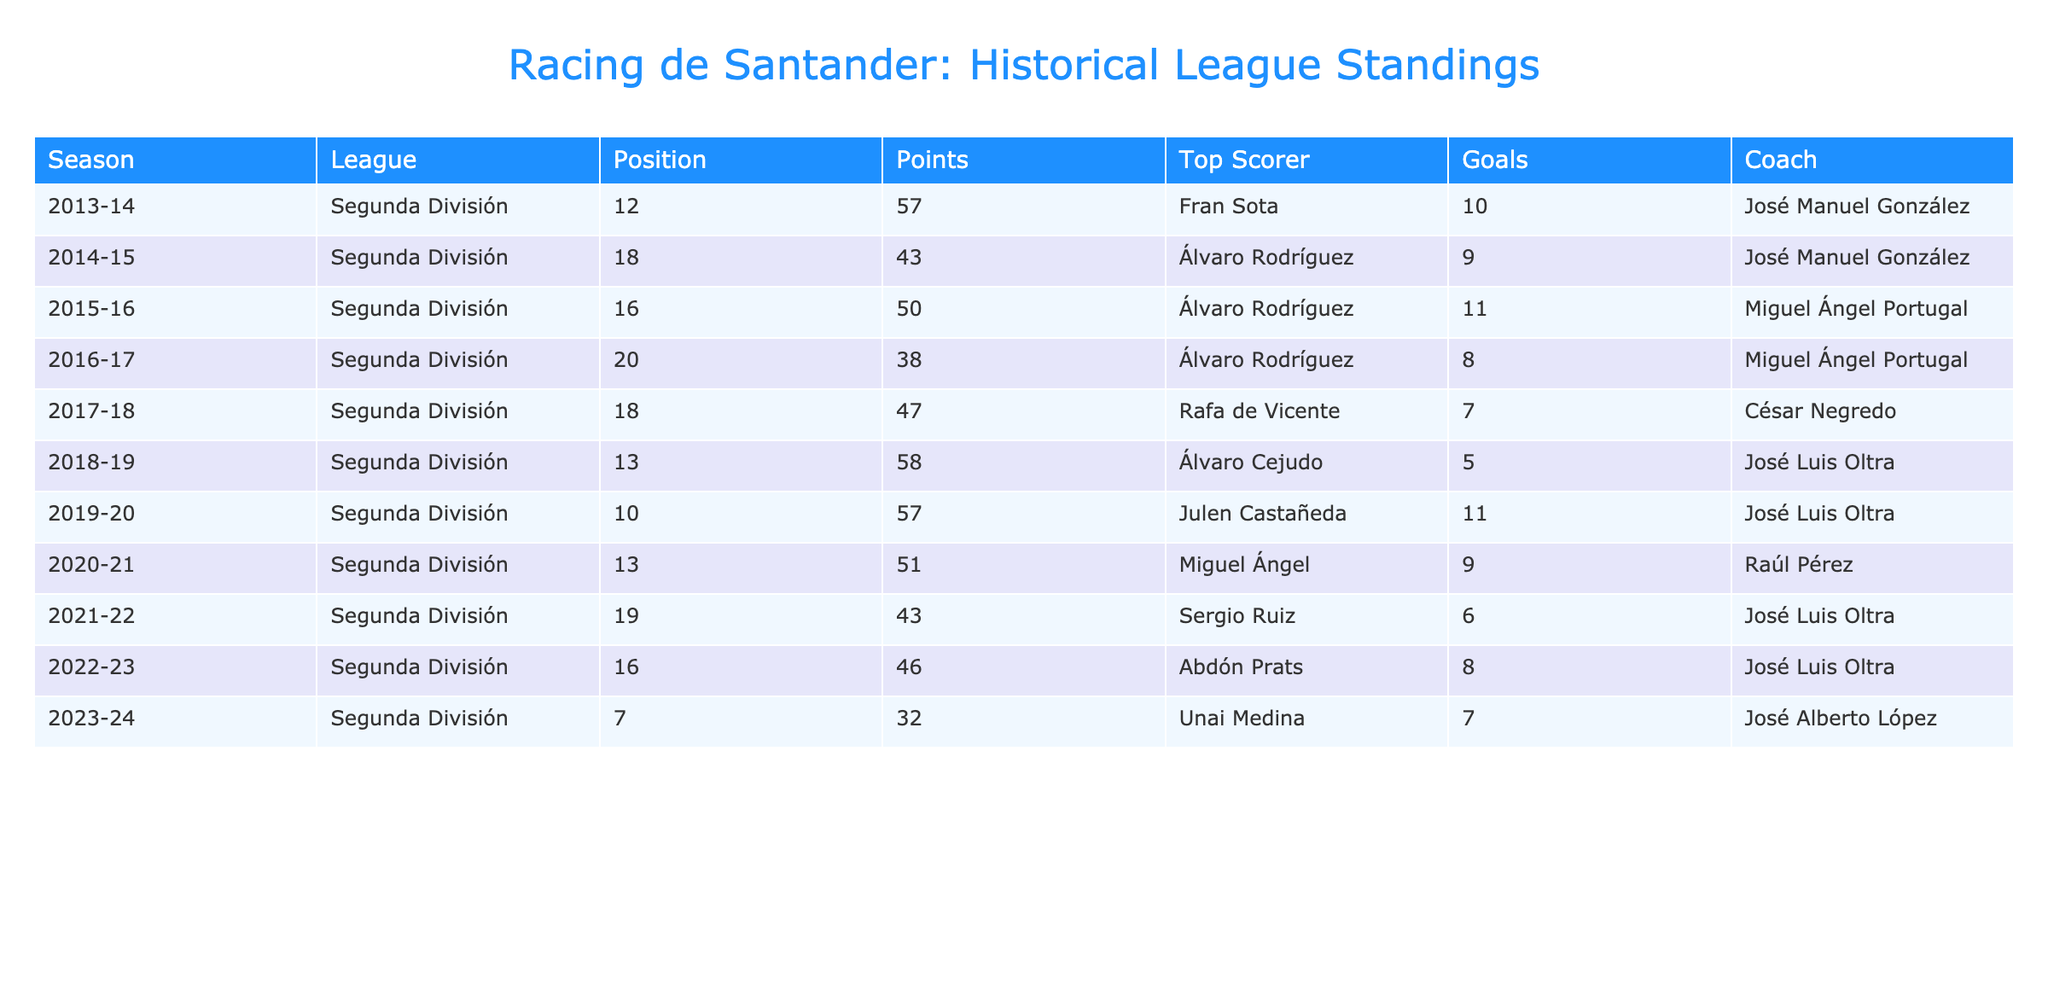What was Racing de Santander's position in the 2021-22 season? Referring to the table, the position listed for the season 2021-22 is 19.
Answer: 19 What is the maximum number of points Racing de Santander earned in the past decade? By reviewing the points column, the highest value is 58, which was achieved in the 2018-19 season.
Answer: 58 Who was Racing de Santander's top scorer in the 2015-16 season? In the 2015-16 season, the top scorer mentioned is Álvaro Rodríguez.
Answer: Álvaro Rodríguez How many goals did the top scorer in the 2019-20 season score? The top scorer for the 2019-20 season, Julen Castañeda, scored 11 goals according to the table.
Answer: 11 What is the average points earned by Racing de Santander over the past decade? To find the average, sum the points (57 + 43 + 50 + 38 + 47 + 58 + 57 + 51 + 43 + 46 + 32 =  466) and divide by 11 seasons (466 / 11 = 42.36). The average is approximately 42.36.
Answer: 42.36 Did Racing de Santander finish in the top half of the league standings in the 2020-21 season? In the 2020-21 season, Racing finished in position 13, which is not in the top half (1-11).
Answer: No Which coach had Racing de Santander during their best points season in the last decade? The best points season was 2018-19 with 58 points, under coach José Luis Oltra.
Answer: José Luis Oltra How many seasons did Racing de Santander finish with less than 50 points? By looking through the points, they finished under 50 points in the following seasons: 2014-15, 2016-17, 2017-18, 2021-22, and 2022-23. That's 5 seasons.
Answer: 5 Which season had the highest scoring player and how many goals did he score? The highest scoring player listed is Álvaro Rodríguez in the 2015-16 season with 11 goals.
Answer: 11 goals in the 2015-16 season What was the change in position from the 2019-20 season to the 2020-21 season? Racing de Santander was in position 10 in the 2019-20 season and dropped to position 13 in the following season, a change of -3 positions.
Answer: -3 positions 